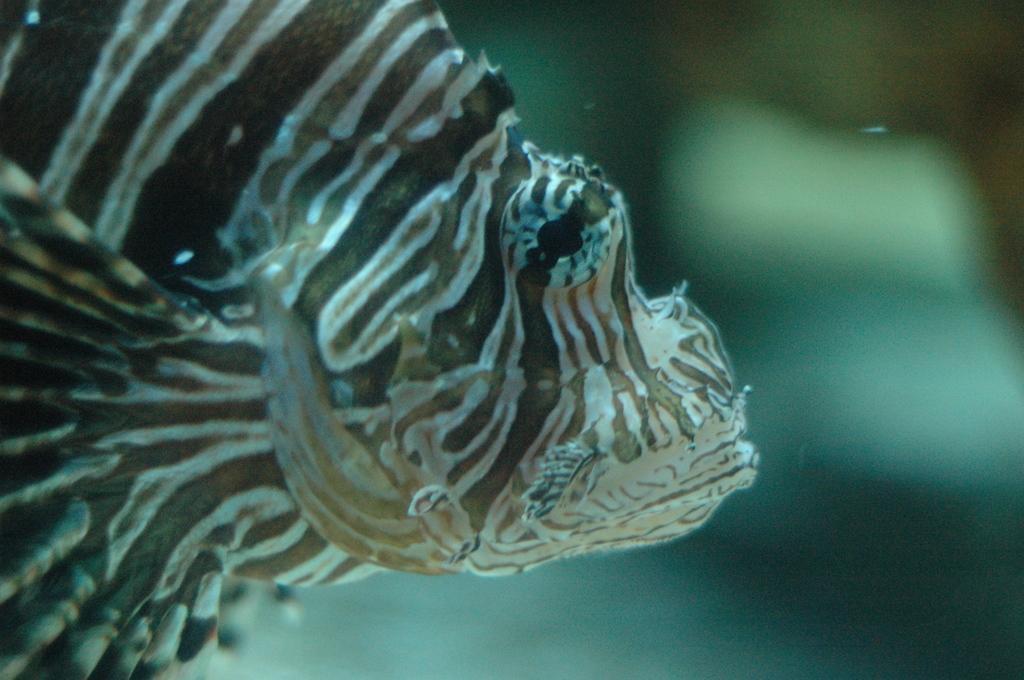Please provide a concise description of this image. In this image we can see a fish in the water. 